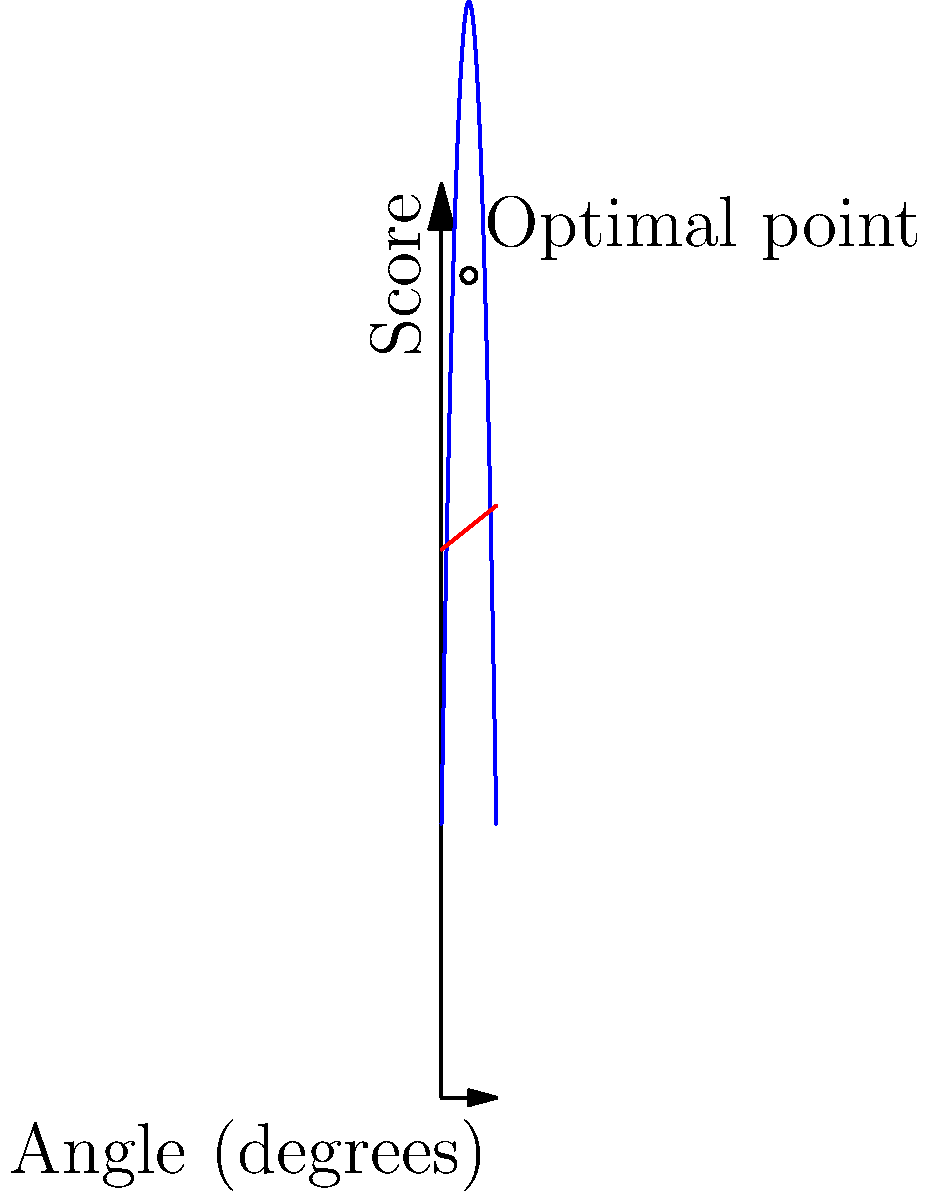As a vocational rehabilitation specialist, you're designing an ergonomic workstation for an injured worker. The graph shows the relationship between the angle of a worker's chair backrest and two factors: worker productivity (blue curve) and discomfort level (red line). The productivity function is given by $P(\theta) = -0.5\theta^2 + 60\theta + 600$, where $\theta$ is the angle in degrees. The discomfort function is $D(\theta) = 0.8\theta + 1200$. 

At what angle $\theta$ should the chair backrest be set to maximize the difference between productivity and discomfort? Round your answer to the nearest degree. To solve this problem, we need to follow these steps:

1) The difference between productivity and discomfort is given by:
   $f(\theta) = P(\theta) - D(\theta) = (-0.5\theta^2 + 60\theta + 600) - (0.8\theta + 1200)$

2) Simplify the function:
   $f(\theta) = -0.5\theta^2 + 59.2\theta - 600$

3) To find the maximum of this function, we need to find where its derivative equals zero:
   $f'(\theta) = -\theta + 59.2$

4) Set $f'(\theta) = 0$ and solve for $\theta$:
   $-\theta + 59.2 = 0$
   $\theta = 59.2$

5) To confirm this is a maximum (not a minimum), check the second derivative:
   $f''(\theta) = -1$, which is negative, confirming a maximum.

6) Rounding to the nearest degree:
   $\theta \approx 59°$

This angle represents the point where the difference between productivity and discomfort is maximized, providing the optimal ergonomic setting for the worker's chair backrest.
Answer: 59° 